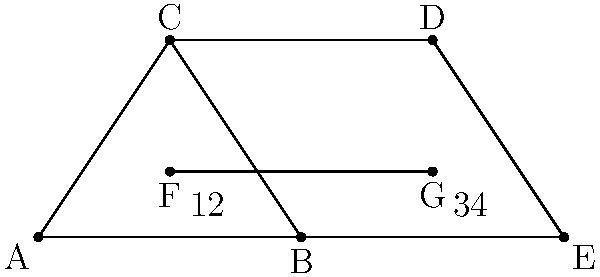In the tessellated design above, how many pairs of congruent triangles can be identified? Justify your answer using the properties of congruent triangles. Let's approach this step-by-step:

1) First, we need to identify all the triangles in the design:
   - Triangle ABC
   - Triangle BCD
   - Triangle CDE
   - Triangles 1, 2, 3, and 4 (formed by line FG)

2) Now, let's check for congruence:

   a) Triangles ABC and CDE:
      - AC = CE (they are both sides of the larger triangle)
      - ∠CAB = ∠CED (alternate angles, as AB || DE)
      - ∠ACA = ∠ECE (vertical angles)
      Therefore, ABC ≅ CDE (AAS congruence)

   b) Triangles 1 and 4:
      - They share the same height (distance from FG to AB or DE)
      - They have the same base (AF = GE)
      - They both have a right angle where FG intersects AB and DE
      Therefore, 1 ≅ 4 (RHS congruence)

   c) Triangles 2 and 3:
      - They share the same height (distance from FG to AB or DE)
      - They have the same base (FB = DG)
      - They both have a right angle where FG intersects AB and DE
      Therefore, 2 ≅ 3 (RHS congruence)

3) In total, we have identified 3 pairs of congruent triangles:
   - ABC and CDE
   - 1 and 4
   - 2 and 3
Answer: 3 pairs 